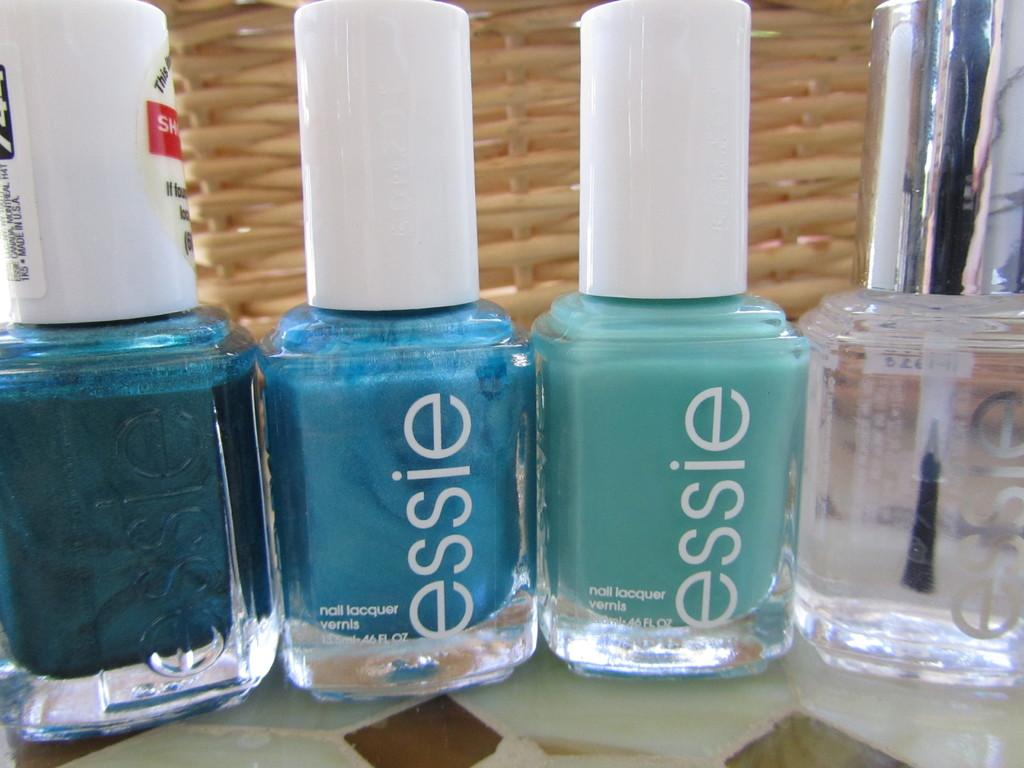What type of items are visible in the image? There are nail polish bottles in the image. Can you describe the appearance of the nail polish bottles? The nail polish bottles are likely colorful and have different shades or designs. Are there any other related items visible in the image? The provided facts do not mention any other related items. What type of soup is being prepared by the fireman in the image? There is no fireman or soup present in the image; it only features nail polish bottles. 